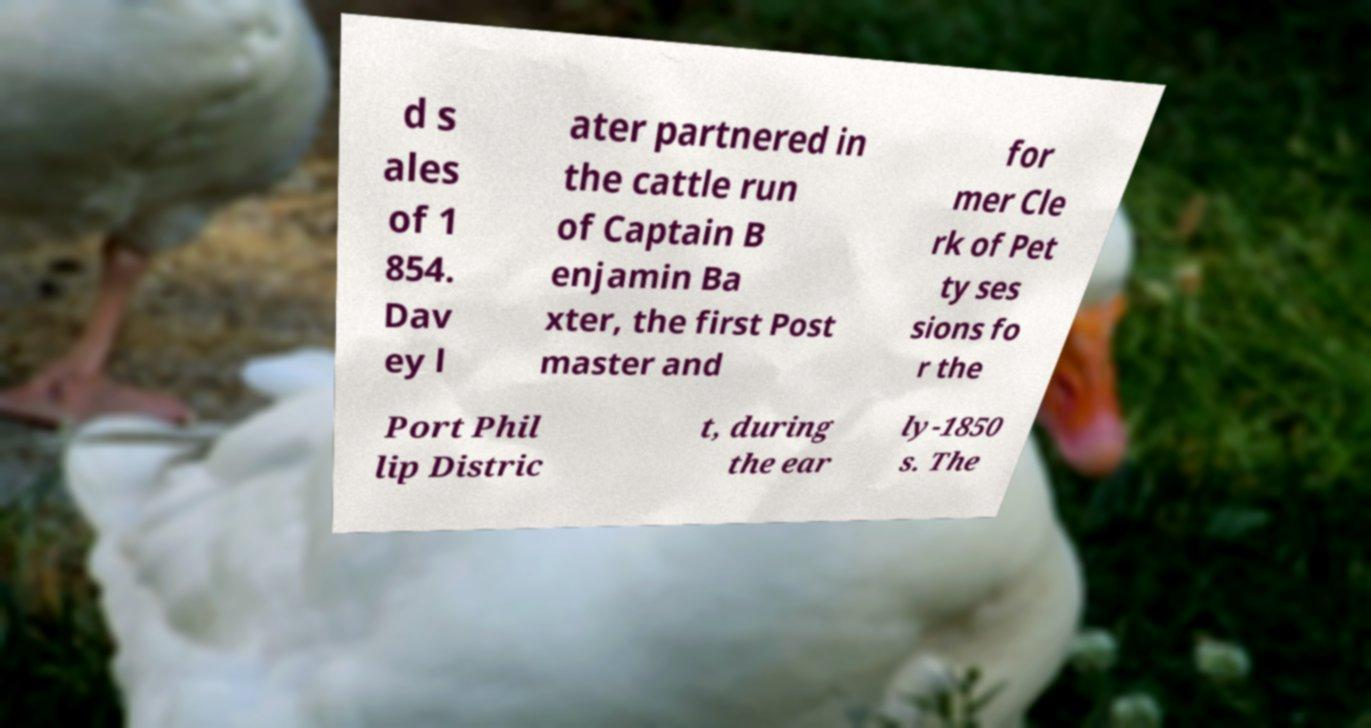I need the written content from this picture converted into text. Can you do that? d s ales of 1 854. Dav ey l ater partnered in the cattle run of Captain B enjamin Ba xter, the first Post master and for mer Cle rk of Pet ty ses sions fo r the Port Phil lip Distric t, during the ear ly-1850 s. The 